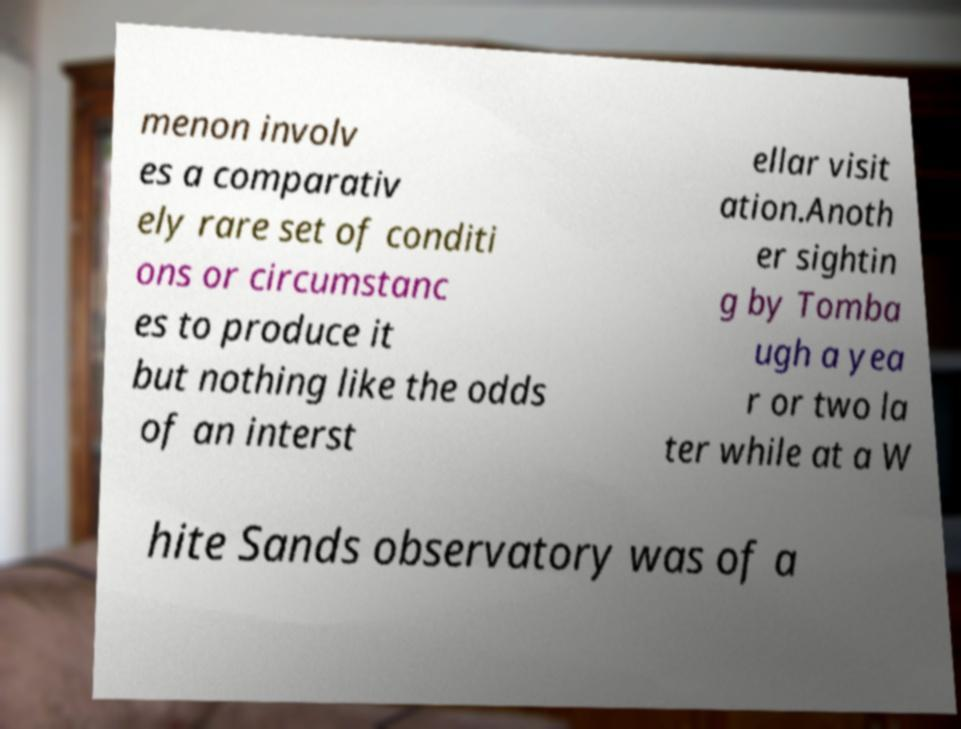There's text embedded in this image that I need extracted. Can you transcribe it verbatim? menon involv es a comparativ ely rare set of conditi ons or circumstanc es to produce it but nothing like the odds of an interst ellar visit ation.Anoth er sightin g by Tomba ugh a yea r or two la ter while at a W hite Sands observatory was of a 